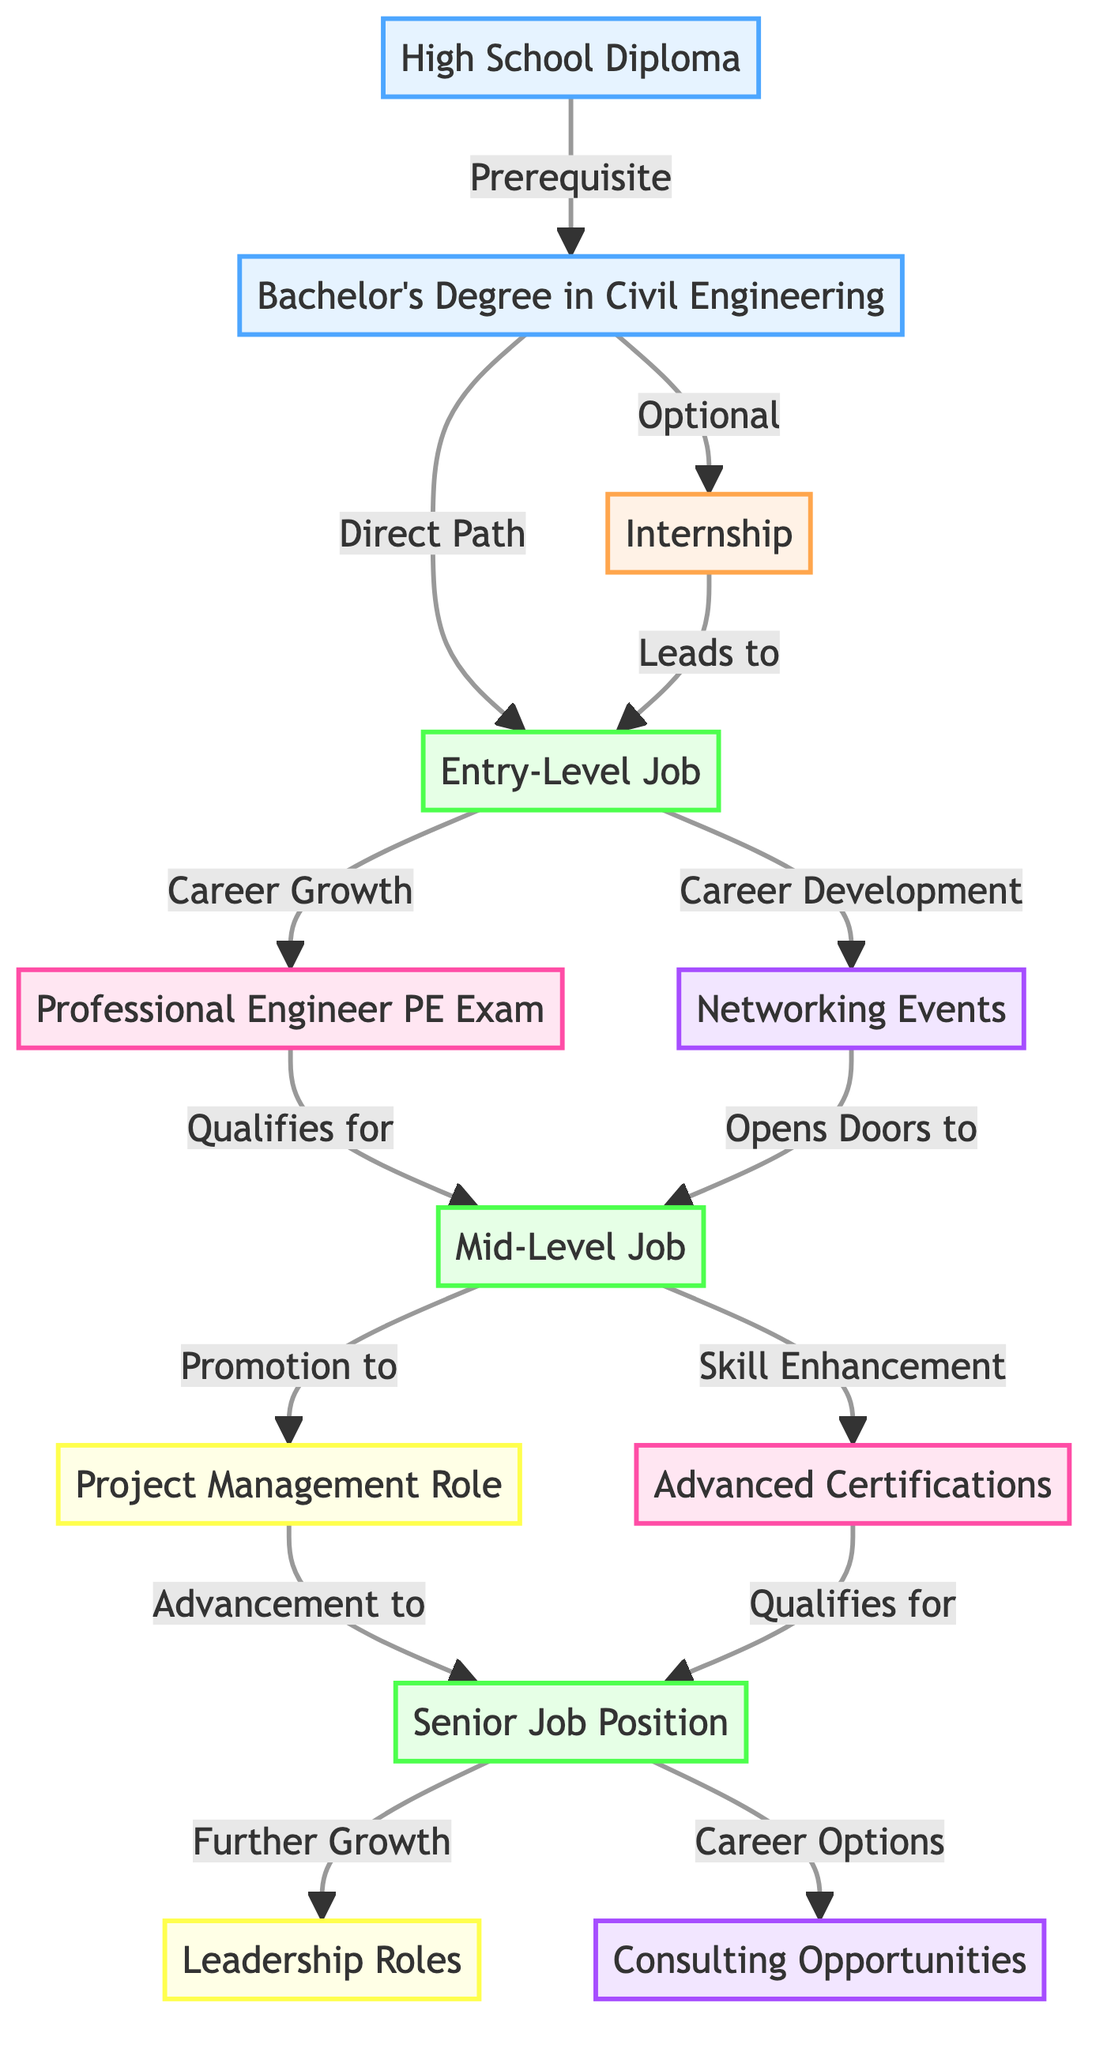What is the first step in the career path of civil engineering? The first node in the diagram is "High School Diploma," which indicates the initial required step before higher education in civil engineering.
Answer: High School Diploma How many employment nodes are in the diagram? By counting the nodes that are classified as "Employment," there are three: "Entry-Level Job," "Mid-Level Job," and "Senior Job Position."
Answer: 3 What follows after obtaining a Bachelor's Degree in Civil Engineering? Based on the diagram, the nodes that come next after "Bachelor's Degree in Civil Engineering" are "Internship" and "Entry-Level Job." However, "Entry-Level Job" is directly accessible as well.
Answer: Internship, Entry-Level Job Which opportunities can lead to a Mid-Level Job? The paths to "Mid-Level Job" can come from two sources: "Professional Engineer (PE) Exam" and "Networking Events." Both of these are connected to the "Entry-Level Job" node.
Answer: Professional Engineer PE Exam, Networking Events What is the prerequisite for taking the Professional Engineer (PE) Exam? To qualify for the "Professional Engineer (PE) Exam," the individual must first achieve an "Entry-Level Job," as indicated by the connections in the diagram showing the need for progress through this position.
Answer: Entry-Level Job Which two paths can lead to a Senior Job Position? The diagram shows that after reaching a "Mid-Level Job," one can advance to a "Senior Job Position" by either pursuing a "Project Management Role" or obtaining "Advanced Certifications."
Answer: Project Management Role, Advanced Certifications How do you transition from an Entry-Level Job to a Mid-Level Job? The transition is facilitated by either passing the "Professional Engineer (PE) Exam" or attending "Networking Events," both of which create pathways leading to the "Mid-Level Job."
Answer: Professional Engineer PE Exam, Networking Events What is the ultimate career advancement step listed in the diagram? The final node signaling the highest career advancement is "Leadership Roles," which is reached after obtaining a "Senior Job Position."
Answer: Leadership Roles Which step is directly connected to Networking Events? The next step that follows from "Networking Events" in the career path is a "Mid-Level Job," indicating that participating in networking opens up opportunities for advancement.
Answer: Mid-Level Job 